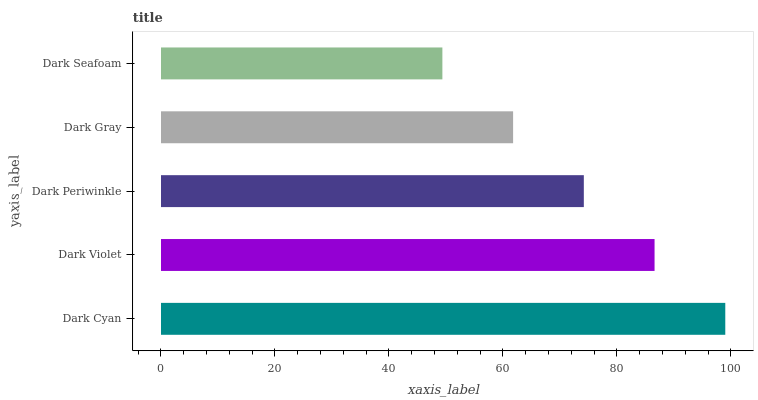Is Dark Seafoam the minimum?
Answer yes or no. Yes. Is Dark Cyan the maximum?
Answer yes or no. Yes. Is Dark Violet the minimum?
Answer yes or no. No. Is Dark Violet the maximum?
Answer yes or no. No. Is Dark Cyan greater than Dark Violet?
Answer yes or no. Yes. Is Dark Violet less than Dark Cyan?
Answer yes or no. Yes. Is Dark Violet greater than Dark Cyan?
Answer yes or no. No. Is Dark Cyan less than Dark Violet?
Answer yes or no. No. Is Dark Periwinkle the high median?
Answer yes or no. Yes. Is Dark Periwinkle the low median?
Answer yes or no. Yes. Is Dark Gray the high median?
Answer yes or no. No. Is Dark Gray the low median?
Answer yes or no. No. 